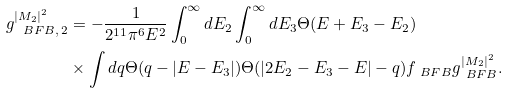Convert formula to latex. <formula><loc_0><loc_0><loc_500><loc_500>g _ { \ B F B , \, 2 } ^ { | M _ { 2 } | ^ { 2 } } & = - \frac { 1 } { 2 ^ { 1 1 } \pi ^ { 6 } E ^ { 2 } } \int _ { 0 } ^ { \infty } d E _ { 2 } \int _ { 0 } ^ { \infty } d E _ { 3 } \Theta ( E + E _ { 3 } - E _ { 2 } ) \\ & \times \int d q \Theta ( q - | E - E _ { 3 } | ) \Theta ( | 2 E _ { 2 } - E _ { 3 } - E | - q ) f _ { \ B F B } g _ { \ B F B } ^ { | M _ { 2 } | ^ { 2 } } .</formula> 